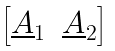Convert formula to latex. <formula><loc_0><loc_0><loc_500><loc_500>\begin{bmatrix} \underline { A } _ { 1 } & \underline { A } _ { 2 } \end{bmatrix}</formula> 